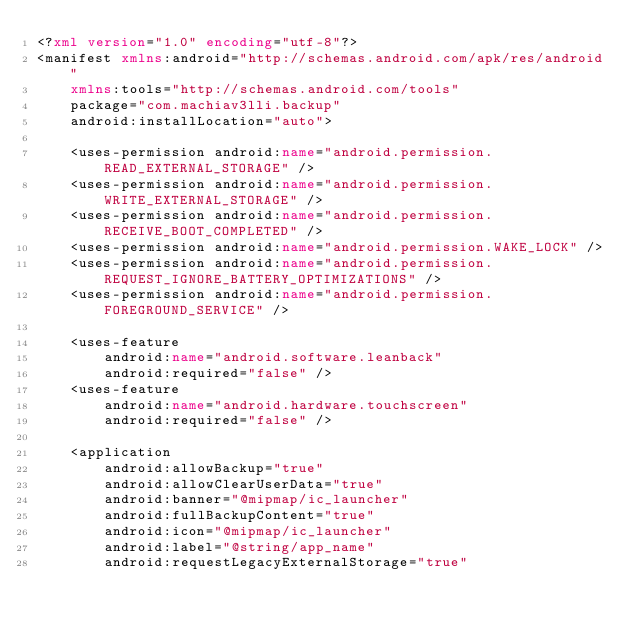Convert code to text. <code><loc_0><loc_0><loc_500><loc_500><_XML_><?xml version="1.0" encoding="utf-8"?>
<manifest xmlns:android="http://schemas.android.com/apk/res/android"
    xmlns:tools="http://schemas.android.com/tools"
    package="com.machiav3lli.backup"
    android:installLocation="auto">

    <uses-permission android:name="android.permission.READ_EXTERNAL_STORAGE" />
    <uses-permission android:name="android.permission.WRITE_EXTERNAL_STORAGE" />
    <uses-permission android:name="android.permission.RECEIVE_BOOT_COMPLETED" />
    <uses-permission android:name="android.permission.WAKE_LOCK" />
    <uses-permission android:name="android.permission.REQUEST_IGNORE_BATTERY_OPTIMIZATIONS" />
    <uses-permission android:name="android.permission.FOREGROUND_SERVICE" />

    <uses-feature
        android:name="android.software.leanback"
        android:required="false" />
    <uses-feature
        android:name="android.hardware.touchscreen"
        android:required="false" />

    <application
        android:allowBackup="true"
        android:allowClearUserData="true"
        android:banner="@mipmap/ic_launcher"
        android:fullBackupContent="true"
        android:icon="@mipmap/ic_launcher"
        android:label="@string/app_name"
        android:requestLegacyExternalStorage="true"</code> 